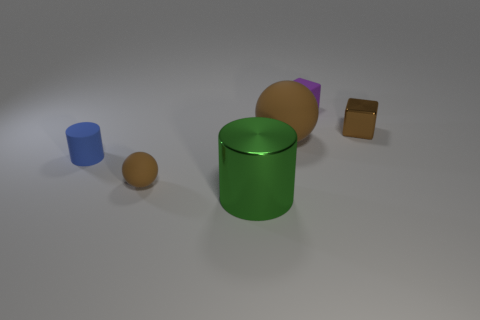Comparing materials, which objects seem to have a similar finish? The green cylinder and the orange sphere both have a reflective, shiny finish, indicating a smooth material, perhaps a polished metal or plastic. In contrast, the purple block appears to have a matte finish, giving it a non-reflective, flat appearance. 